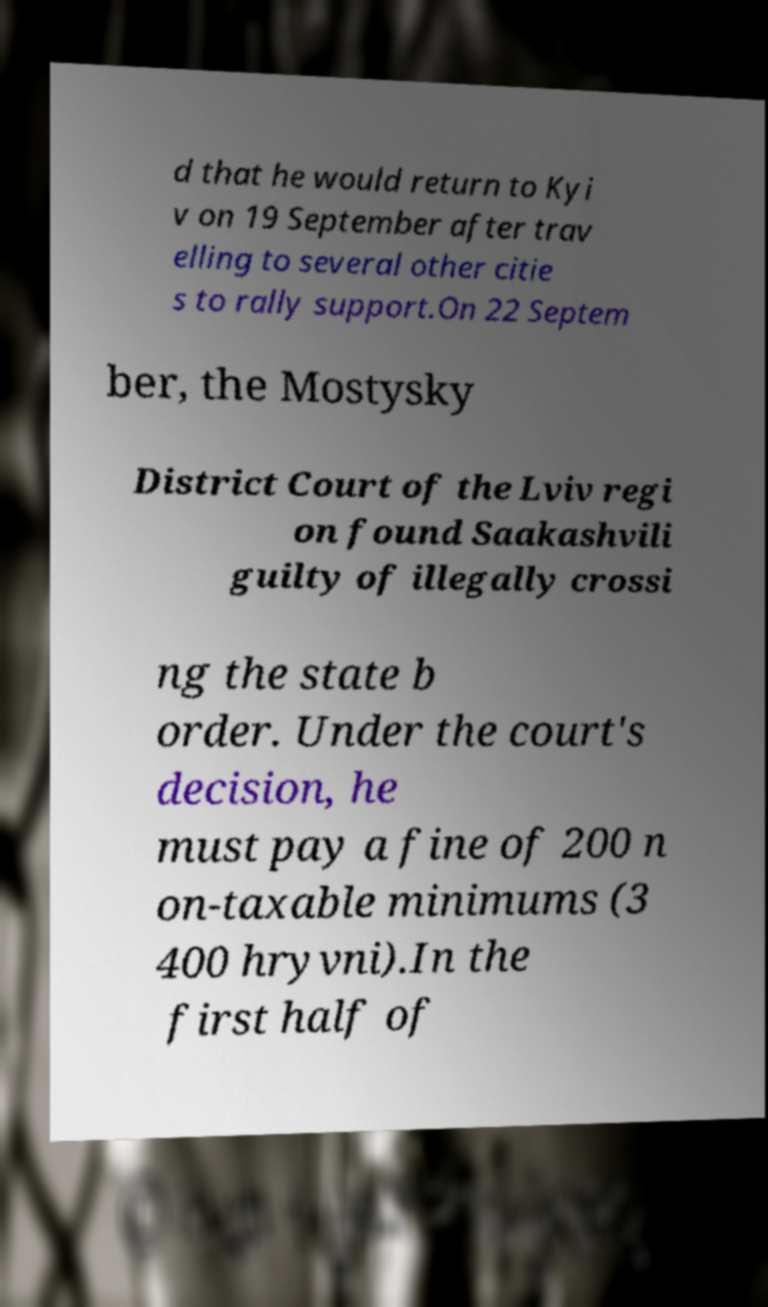There's text embedded in this image that I need extracted. Can you transcribe it verbatim? d that he would return to Kyi v on 19 September after trav elling to several other citie s to rally support.On 22 Septem ber, the Mostysky District Court of the Lviv regi on found Saakashvili guilty of illegally crossi ng the state b order. Under the court's decision, he must pay a fine of 200 n on-taxable minimums (3 400 hryvni).In the first half of 